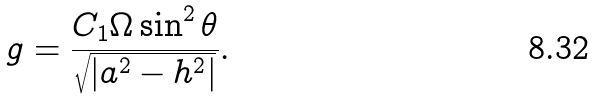<formula> <loc_0><loc_0><loc_500><loc_500>g = \frac { C _ { 1 } \Omega \sin ^ { 2 } \theta } { \sqrt { | a ^ { 2 } - h ^ { 2 } | } } .</formula> 